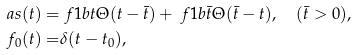<formula> <loc_0><loc_0><loc_500><loc_500>\ a s ( t ) = & \ f { 1 } { b t } \Theta ( t - \bar { t } ) + \ f { 1 } { b \bar { t } } \Theta ( \bar { t } - t ) , \quad ( \bar { t } > 0 ) , \\ f _ { 0 } ( t ) = & \delta ( t - t _ { 0 } ) ,</formula> 